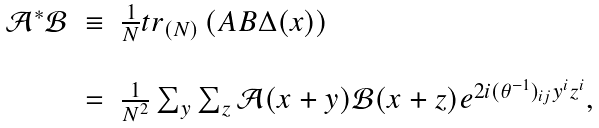<formula> <loc_0><loc_0><loc_500><loc_500>\begin{array} { r c l } \mathcal { A } ^ { * } \mathcal { B } & \equiv & \frac { 1 } { N } t r _ { ( N ) } \left ( A B \Delta ( x ) \right ) \\ \\ & = & \frac { 1 } { N ^ { 2 } } \sum _ { y } \sum _ { z } \mathcal { A } ( x + y ) \mathcal { B } ( x + z ) e ^ { 2 i ( \theta ^ { - 1 } ) _ { i j } y ^ { i } z ^ { i } } , \end{array}</formula> 